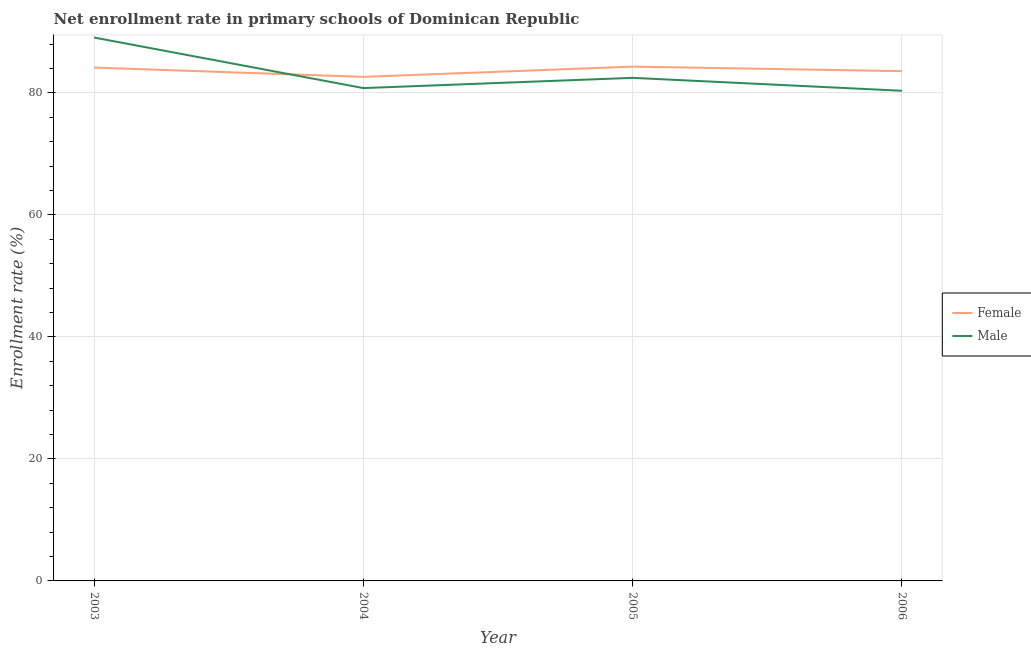How many different coloured lines are there?
Provide a succinct answer. 2. What is the enrollment rate of female students in 2003?
Offer a very short reply. 84.14. Across all years, what is the maximum enrollment rate of male students?
Provide a succinct answer. 89.06. Across all years, what is the minimum enrollment rate of female students?
Make the answer very short. 82.62. What is the total enrollment rate of male students in the graph?
Give a very brief answer. 332.64. What is the difference between the enrollment rate of male students in 2004 and that in 2006?
Your response must be concise. 0.44. What is the difference between the enrollment rate of male students in 2004 and the enrollment rate of female students in 2003?
Provide a short and direct response. -3.36. What is the average enrollment rate of male students per year?
Provide a succinct answer. 83.16. In the year 2005, what is the difference between the enrollment rate of male students and enrollment rate of female students?
Provide a succinct answer. -1.84. In how many years, is the enrollment rate of male students greater than 56 %?
Ensure brevity in your answer.  4. What is the ratio of the enrollment rate of male students in 2003 to that in 2004?
Your answer should be compact. 1.1. Is the enrollment rate of female students in 2003 less than that in 2005?
Offer a very short reply. Yes. What is the difference between the highest and the second highest enrollment rate of male students?
Provide a short and direct response. 6.61. What is the difference between the highest and the lowest enrollment rate of female students?
Make the answer very short. 1.68. Is the sum of the enrollment rate of male students in 2005 and 2006 greater than the maximum enrollment rate of female students across all years?
Your response must be concise. Yes. Does the enrollment rate of male students monotonically increase over the years?
Keep it short and to the point. No. Is the enrollment rate of female students strictly greater than the enrollment rate of male students over the years?
Offer a terse response. No. Is the enrollment rate of male students strictly less than the enrollment rate of female students over the years?
Ensure brevity in your answer.  No. How many lines are there?
Your answer should be very brief. 2. How many years are there in the graph?
Your answer should be very brief. 4. What is the difference between two consecutive major ticks on the Y-axis?
Your answer should be very brief. 20. Does the graph contain grids?
Your response must be concise. Yes. How many legend labels are there?
Offer a terse response. 2. How are the legend labels stacked?
Ensure brevity in your answer.  Vertical. What is the title of the graph?
Your response must be concise. Net enrollment rate in primary schools of Dominican Republic. Does "External balance on goods" appear as one of the legend labels in the graph?
Provide a succinct answer. No. What is the label or title of the Y-axis?
Keep it short and to the point. Enrollment rate (%). What is the Enrollment rate (%) of Female in 2003?
Give a very brief answer. 84.14. What is the Enrollment rate (%) in Male in 2003?
Offer a very short reply. 89.06. What is the Enrollment rate (%) in Female in 2004?
Offer a very short reply. 82.62. What is the Enrollment rate (%) in Male in 2004?
Offer a very short reply. 80.78. What is the Enrollment rate (%) of Female in 2005?
Ensure brevity in your answer.  84.3. What is the Enrollment rate (%) in Male in 2005?
Offer a very short reply. 82.46. What is the Enrollment rate (%) in Female in 2006?
Keep it short and to the point. 83.56. What is the Enrollment rate (%) of Male in 2006?
Make the answer very short. 80.34. Across all years, what is the maximum Enrollment rate (%) of Female?
Keep it short and to the point. 84.3. Across all years, what is the maximum Enrollment rate (%) in Male?
Give a very brief answer. 89.06. Across all years, what is the minimum Enrollment rate (%) in Female?
Your answer should be compact. 82.62. Across all years, what is the minimum Enrollment rate (%) in Male?
Your response must be concise. 80.34. What is the total Enrollment rate (%) in Female in the graph?
Your answer should be very brief. 334.61. What is the total Enrollment rate (%) of Male in the graph?
Offer a very short reply. 332.64. What is the difference between the Enrollment rate (%) in Female in 2003 and that in 2004?
Give a very brief answer. 1.52. What is the difference between the Enrollment rate (%) of Male in 2003 and that in 2004?
Your response must be concise. 8.29. What is the difference between the Enrollment rate (%) in Female in 2003 and that in 2005?
Provide a short and direct response. -0.16. What is the difference between the Enrollment rate (%) of Male in 2003 and that in 2005?
Keep it short and to the point. 6.61. What is the difference between the Enrollment rate (%) of Female in 2003 and that in 2006?
Provide a short and direct response. 0.59. What is the difference between the Enrollment rate (%) of Male in 2003 and that in 2006?
Give a very brief answer. 8.73. What is the difference between the Enrollment rate (%) in Female in 2004 and that in 2005?
Keep it short and to the point. -1.68. What is the difference between the Enrollment rate (%) of Male in 2004 and that in 2005?
Offer a very short reply. -1.68. What is the difference between the Enrollment rate (%) of Female in 2004 and that in 2006?
Offer a very short reply. -0.94. What is the difference between the Enrollment rate (%) in Male in 2004 and that in 2006?
Keep it short and to the point. 0.44. What is the difference between the Enrollment rate (%) in Female in 2005 and that in 2006?
Give a very brief answer. 0.74. What is the difference between the Enrollment rate (%) in Male in 2005 and that in 2006?
Provide a succinct answer. 2.12. What is the difference between the Enrollment rate (%) of Female in 2003 and the Enrollment rate (%) of Male in 2004?
Your answer should be compact. 3.36. What is the difference between the Enrollment rate (%) of Female in 2003 and the Enrollment rate (%) of Male in 2005?
Offer a terse response. 1.68. What is the difference between the Enrollment rate (%) in Female in 2003 and the Enrollment rate (%) in Male in 2006?
Provide a short and direct response. 3.8. What is the difference between the Enrollment rate (%) in Female in 2004 and the Enrollment rate (%) in Male in 2005?
Your response must be concise. 0.16. What is the difference between the Enrollment rate (%) of Female in 2004 and the Enrollment rate (%) of Male in 2006?
Your answer should be compact. 2.28. What is the difference between the Enrollment rate (%) in Female in 2005 and the Enrollment rate (%) in Male in 2006?
Provide a short and direct response. 3.96. What is the average Enrollment rate (%) of Female per year?
Keep it short and to the point. 83.65. What is the average Enrollment rate (%) in Male per year?
Give a very brief answer. 83.16. In the year 2003, what is the difference between the Enrollment rate (%) of Female and Enrollment rate (%) of Male?
Your answer should be compact. -4.92. In the year 2004, what is the difference between the Enrollment rate (%) of Female and Enrollment rate (%) of Male?
Give a very brief answer. 1.84. In the year 2005, what is the difference between the Enrollment rate (%) of Female and Enrollment rate (%) of Male?
Offer a very short reply. 1.84. In the year 2006, what is the difference between the Enrollment rate (%) in Female and Enrollment rate (%) in Male?
Offer a very short reply. 3.22. What is the ratio of the Enrollment rate (%) in Female in 2003 to that in 2004?
Offer a very short reply. 1.02. What is the ratio of the Enrollment rate (%) in Male in 2003 to that in 2004?
Your answer should be compact. 1.1. What is the ratio of the Enrollment rate (%) in Female in 2003 to that in 2005?
Provide a succinct answer. 1. What is the ratio of the Enrollment rate (%) of Male in 2003 to that in 2005?
Make the answer very short. 1.08. What is the ratio of the Enrollment rate (%) of Male in 2003 to that in 2006?
Keep it short and to the point. 1.11. What is the ratio of the Enrollment rate (%) of Female in 2004 to that in 2005?
Make the answer very short. 0.98. What is the ratio of the Enrollment rate (%) in Male in 2004 to that in 2005?
Your answer should be compact. 0.98. What is the ratio of the Enrollment rate (%) of Female in 2005 to that in 2006?
Provide a short and direct response. 1.01. What is the ratio of the Enrollment rate (%) of Male in 2005 to that in 2006?
Provide a short and direct response. 1.03. What is the difference between the highest and the second highest Enrollment rate (%) of Female?
Offer a terse response. 0.16. What is the difference between the highest and the second highest Enrollment rate (%) in Male?
Ensure brevity in your answer.  6.61. What is the difference between the highest and the lowest Enrollment rate (%) in Female?
Keep it short and to the point. 1.68. What is the difference between the highest and the lowest Enrollment rate (%) in Male?
Your answer should be very brief. 8.73. 